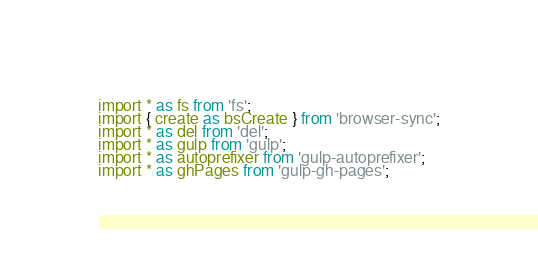<code> <loc_0><loc_0><loc_500><loc_500><_TypeScript_>import * as fs from 'fs';
import { create as bsCreate } from 'browser-sync';
import * as del from 'del';
import * as gulp from 'gulp';
import * as autoprefixer from 'gulp-autoprefixer';
import * as ghPages from 'gulp-gh-pages';</code> 